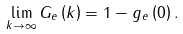Convert formula to latex. <formula><loc_0><loc_0><loc_500><loc_500>\lim _ { k \to \infty } G _ { e } \left ( k \right ) = 1 - g _ { e } \left ( 0 \right ) .</formula> 